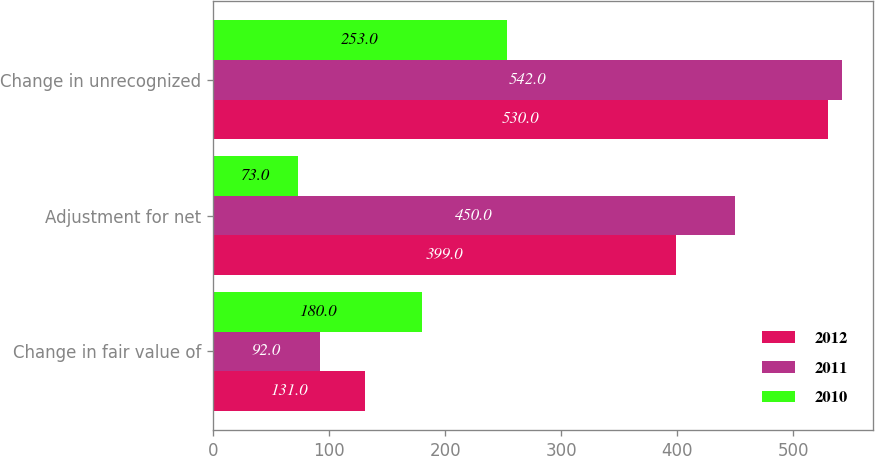Convert chart. <chart><loc_0><loc_0><loc_500><loc_500><stacked_bar_chart><ecel><fcel>Change in fair value of<fcel>Adjustment for net<fcel>Change in unrecognized<nl><fcel>2012<fcel>131<fcel>399<fcel>530<nl><fcel>2011<fcel>92<fcel>450<fcel>542<nl><fcel>2010<fcel>180<fcel>73<fcel>253<nl></chart> 